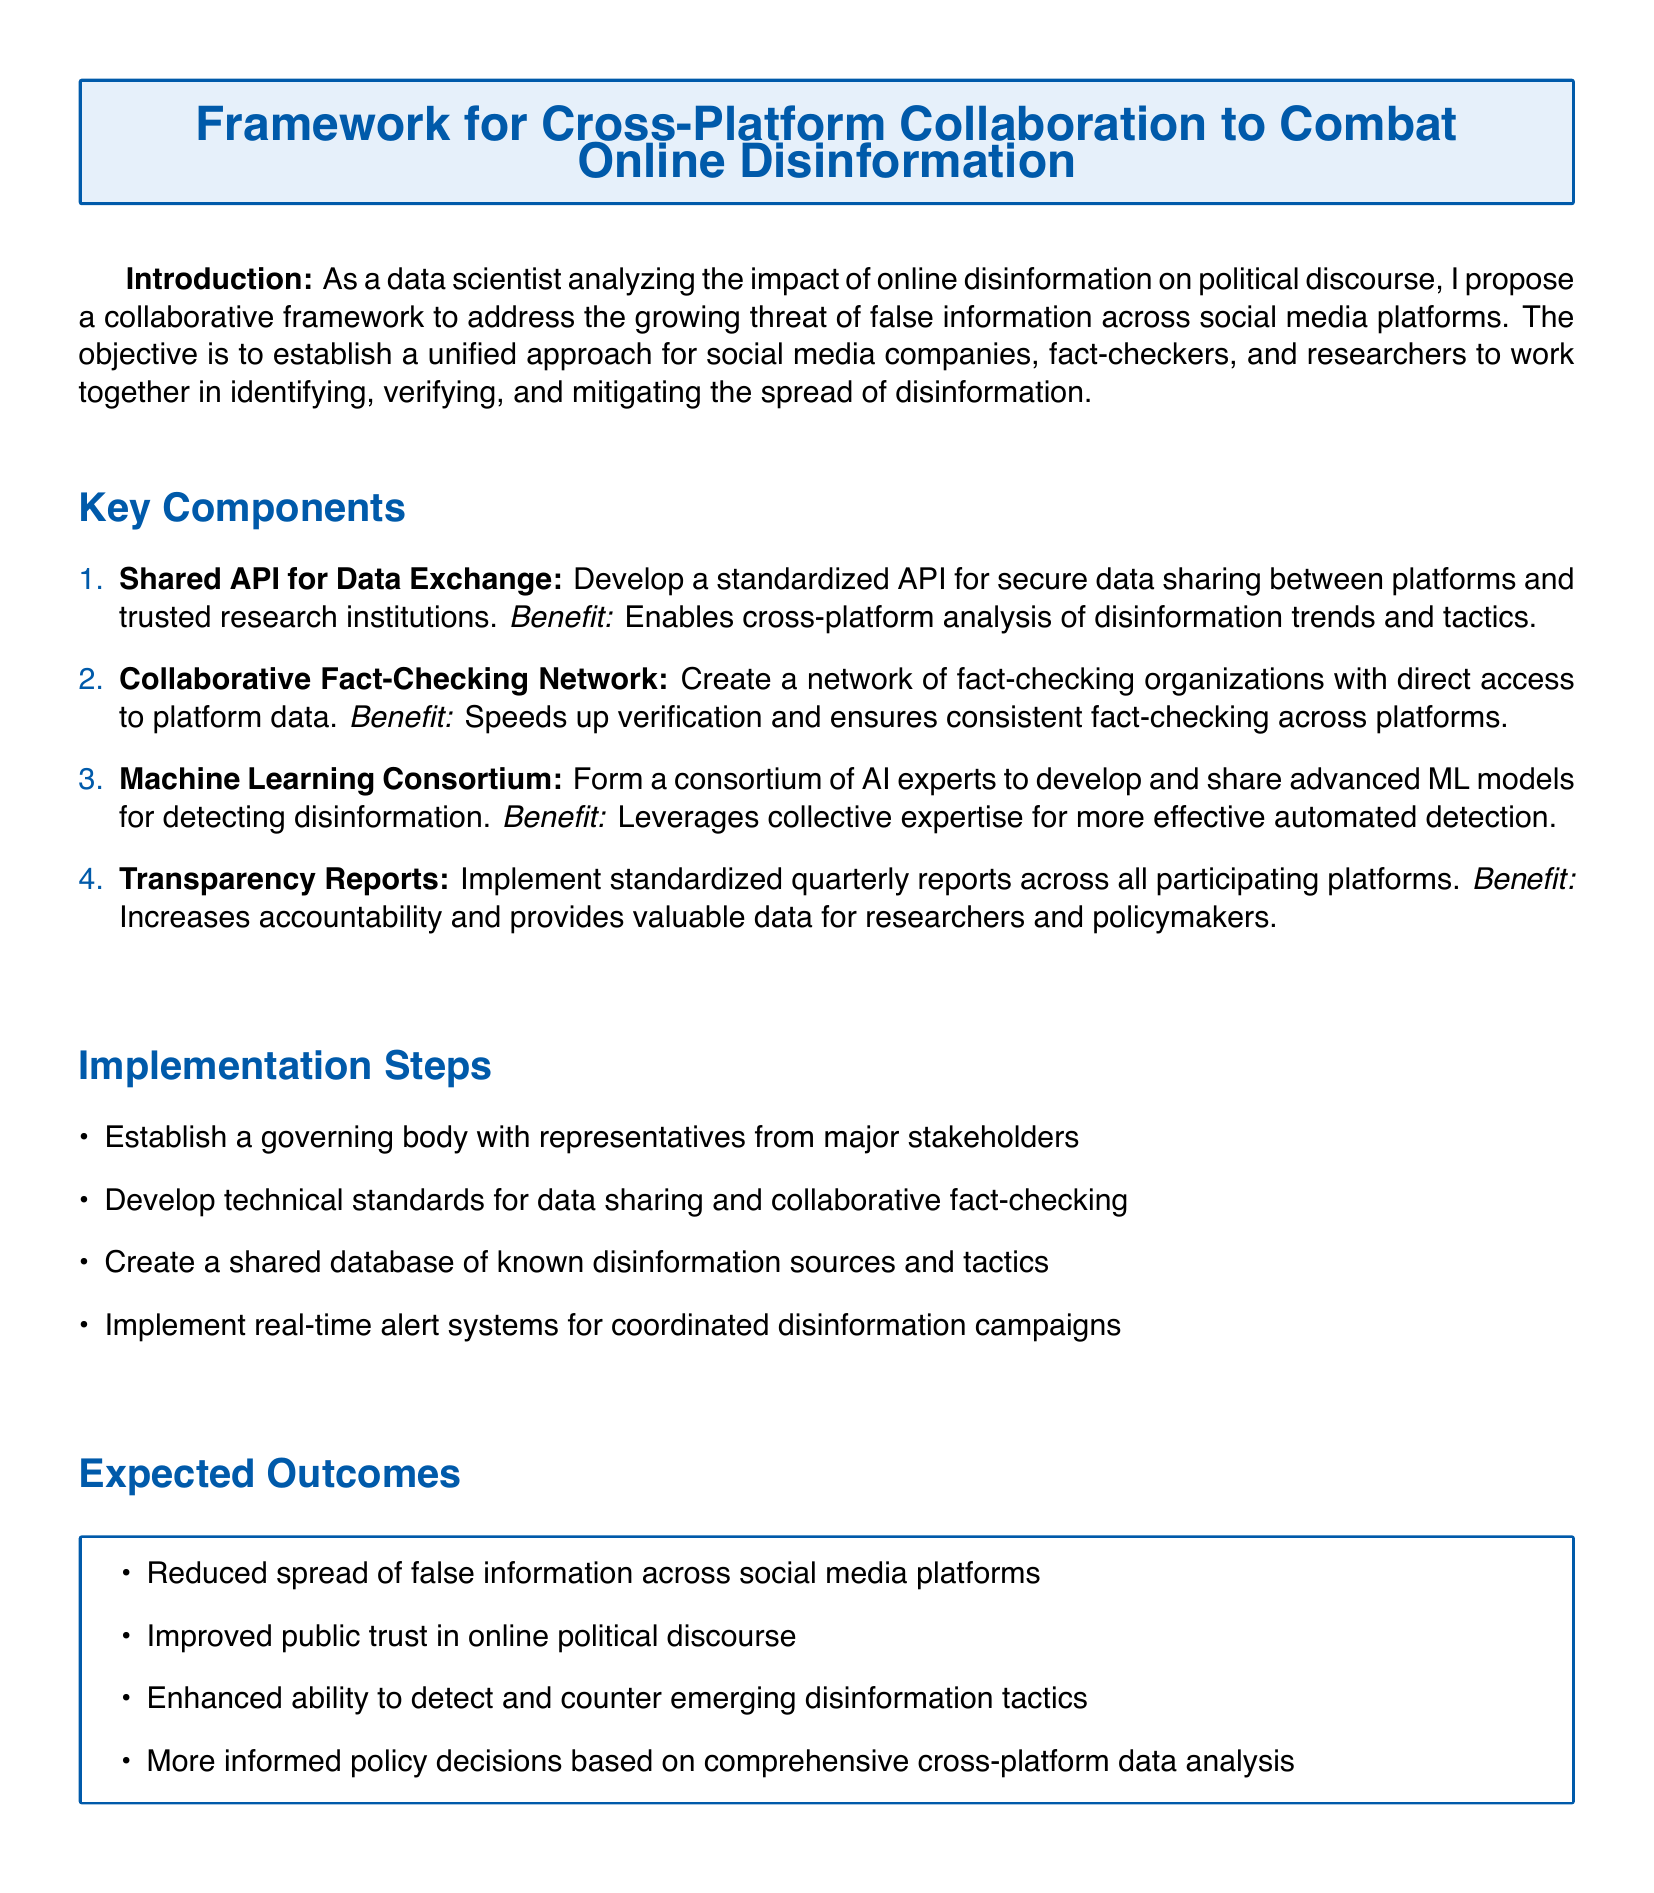What is the title of the document? The title is explicitly stated in the header of the document.
Answer: Framework for Cross-Platform Collaboration to Combat Online Disinformation How many key components are listed in the document? The number of key components is indicated by the list format used.
Answer: 4 What is the first key component mentioned? The first key component is clearly outlined at the beginning of the list provided.
Answer: Shared API for Data Exchange What is one benefit of the Collaborative Fact-Checking Network? The benefit is specifically mentioned following the description of the component.
Answer: Speeds up verification Who is responsible for establishing the governing body? The document suggests involvement from major stakeholders for this step.
Answer: Major stakeholders What type of reports are to be implemented across platforms? The document specifies the type of reports that are required for accountability.
Answer: Transparency Reports What is the expected outcome related to public trust? The document outlines the improvement expected in relation to public trust.
Answer: Improved public trust in online political discourse What is one implementation step mentioned? Specific steps are provided under the implementation section of the document.
Answer: Establish a governing body How frequently will the transparency reports be issued? The frequency of reporting is stated in the description of the transparency reports.
Answer: Quarterly 